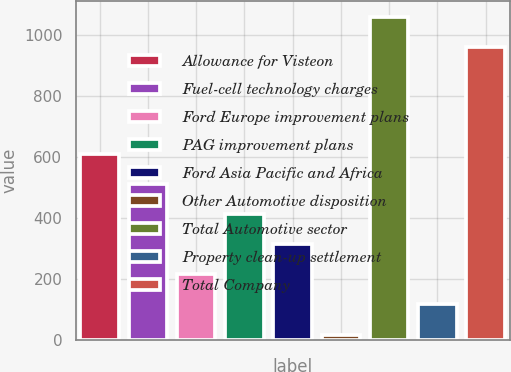<chart> <loc_0><loc_0><loc_500><loc_500><bar_chart><fcel>Allowance for Visteon<fcel>Fuel-cell technology charges<fcel>Ford Europe improvement plans<fcel>PAG improvement plans<fcel>Ford Asia Pacific and Africa<fcel>Other Automotive disposition<fcel>Total Automotive sector<fcel>Property clean-up settlement<fcel>Total Company<nl><fcel>609.8<fcel>511<fcel>214.6<fcel>412.2<fcel>313.4<fcel>17<fcel>1058.8<fcel>115.8<fcel>960<nl></chart> 